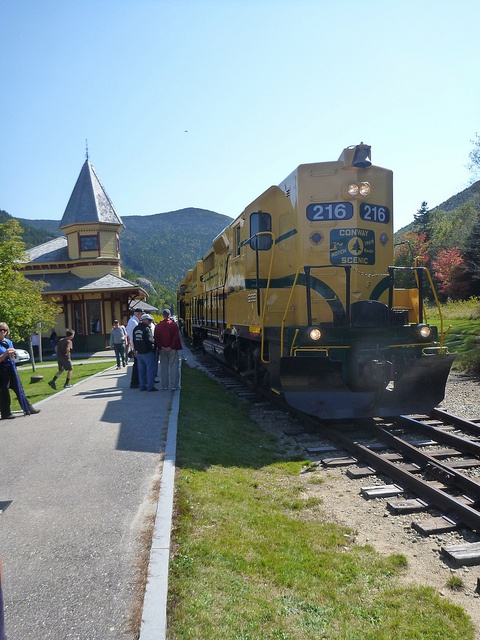Describe the objects in this image and their specific colors. I can see train in lightblue, black, gray, and olive tones, people in lightblue, black, navy, darkblue, and purple tones, people in lightblue, black, gray, navy, and darkgray tones, people in lightblue, black, navy, and gray tones, and people in lightblue, black, gray, darkgreen, and darkgray tones in this image. 